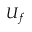<formula> <loc_0><loc_0><loc_500><loc_500>U _ { f }</formula> 